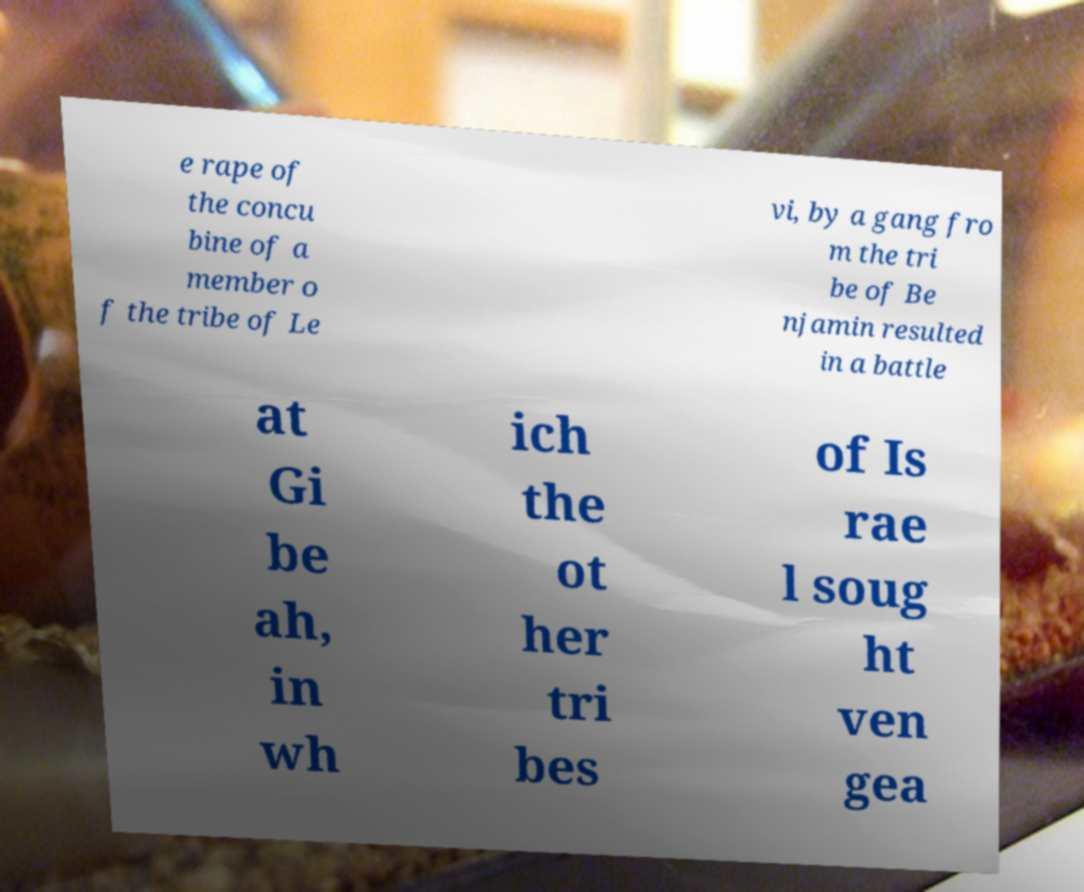Please read and relay the text visible in this image. What does it say? e rape of the concu bine of a member o f the tribe of Le vi, by a gang fro m the tri be of Be njamin resulted in a battle at Gi be ah, in wh ich the ot her tri bes of Is rae l soug ht ven gea 